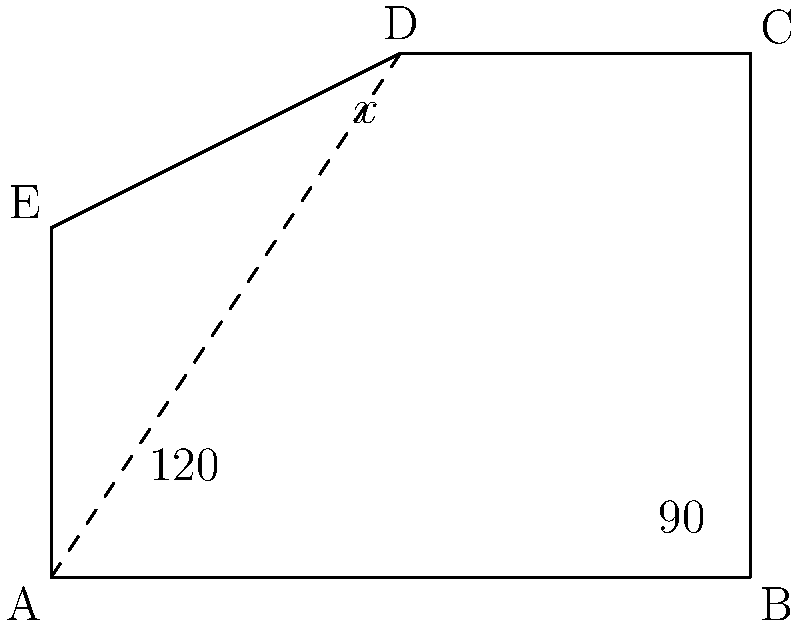In a polygonal office layout, safety regulations require that all interior angles be less than $150°$. Given the floor plan shown, where angle BAE is $120°$ and angle ABC is $90°$, what is the maximum value of angle CDE (represented by $x°$) that would comply with the safety regulations? To solve this problem, we need to follow these steps:

1) First, recall that the sum of interior angles of a pentagon is $(5-2) \times 180° = 540°$.

2) We know two angles:
   - Angle BAE = $120°$
   - Angle ABC = $90°$

3) Let's call the unknown angles:
   - Angle BCD = $y°$
   - Angle AED = $z°$

4) We can set up an equation:
   $120° + 90° + y° + x° + z° = 540°$

5) Simplify:
   $210° + y° + x° + z° = 540°$
   $y° + x° + z° = 330°$

6) The question asks for the maximum value of $x°$ that complies with regulations. This will occur when $y°$ and $z°$ are at their minimum allowed values, which is just under $150°$ each.

7) Let's set $y° = z° = 149.99°$ (slightly less than $150°$ to comply with regulations):
   $149.99° + x° + 149.99° = 330°$
   $x° = 330° - 299.98° = 30.02°$

8) Therefore, the maximum value of $x°$ that complies with regulations is $30.02°$.
Answer: $30.02°$ 